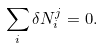<formula> <loc_0><loc_0><loc_500><loc_500>\sum _ { i } \delta N _ { i } ^ { j } = 0 .</formula> 